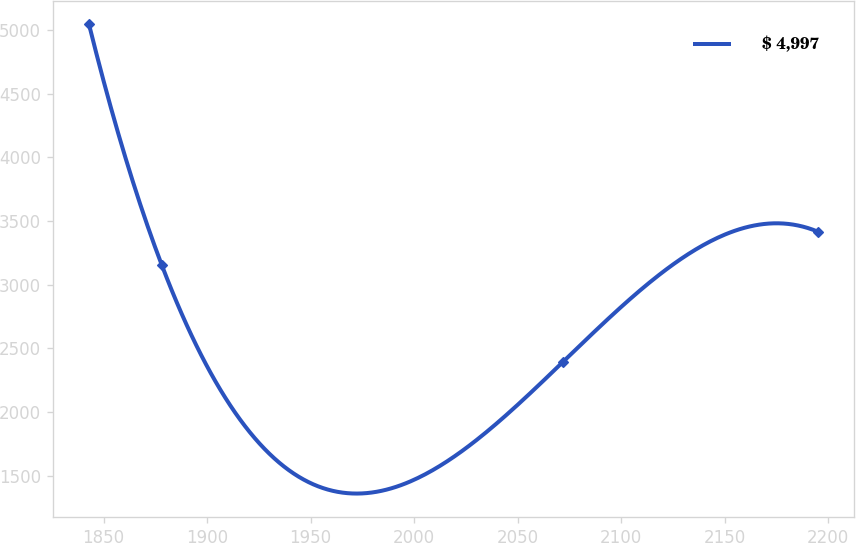<chart> <loc_0><loc_0><loc_500><loc_500><line_chart><ecel><fcel>$ 4,997<nl><fcel>1842.99<fcel>5043.19<nl><fcel>1878.17<fcel>3152.35<nl><fcel>2071.86<fcel>2393.85<nl><fcel>2194.79<fcel>3417.28<nl></chart> 